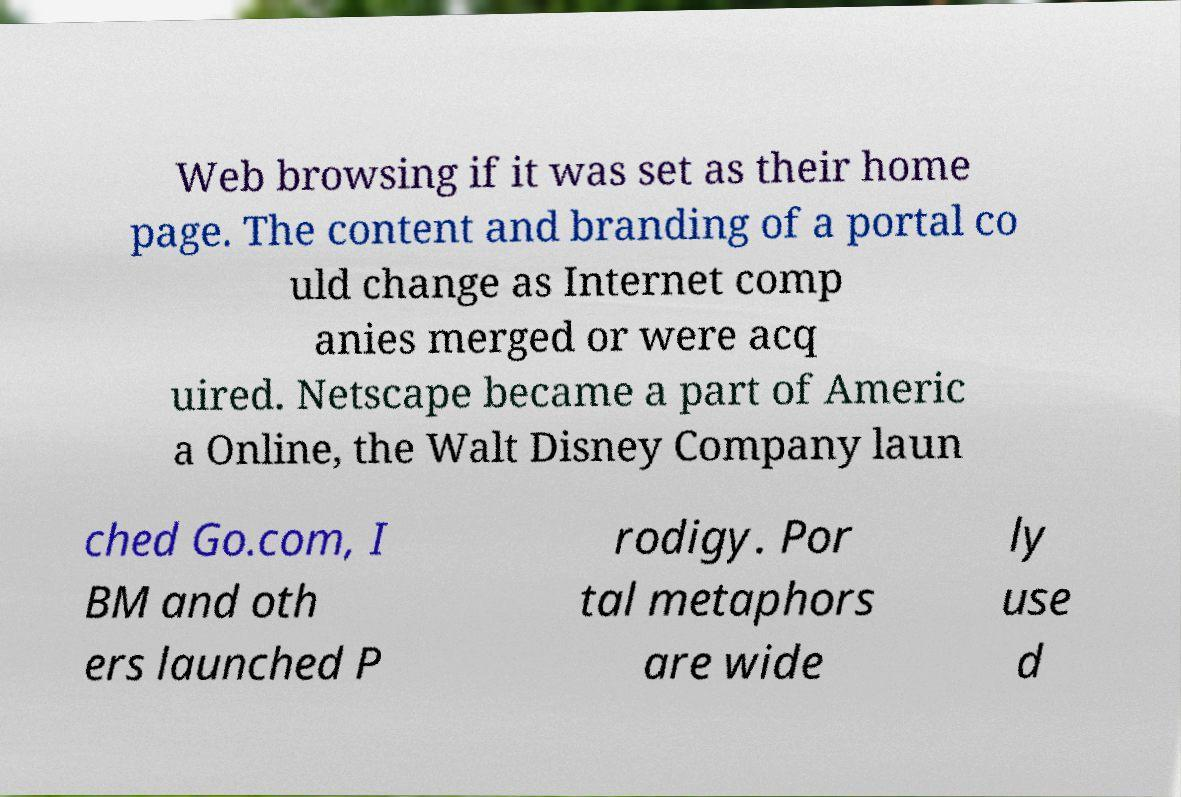Could you extract and type out the text from this image? Web browsing if it was set as their home page. The content and branding of a portal co uld change as Internet comp anies merged or were acq uired. Netscape became a part of Americ a Online, the Walt Disney Company laun ched Go.com, I BM and oth ers launched P rodigy. Por tal metaphors are wide ly use d 